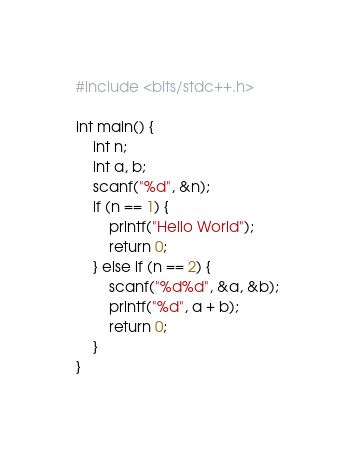<code> <loc_0><loc_0><loc_500><loc_500><_C++_>#include <bits/stdc++.h>

int main() {
    int n;
    int a, b;
    scanf("%d", &n);
    if (n == 1) {
        printf("Hello World");
        return 0;
    } else if (n == 2) {
        scanf("%d%d", &a, &b);
        printf("%d", a + b);
        return 0;
    }
}
</code> 